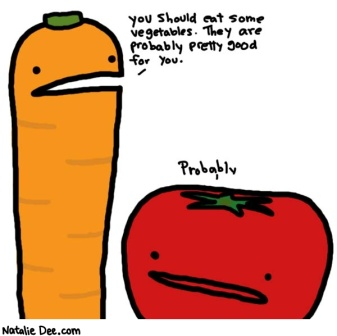Describe the following image. The image is a comical cartoon showcasing two anthropomorphic vegetables: a carrot and a tomato. The carrot, positioned on the left, is brightly colored orange with a green top. It has a slightly disgruntled face, giving it a humorous expression. On the right side is a red tomato with a green stem. The tomato also has a frowning face, mimicking the carrot's expression. There's a humorous dialogue between the two: above the carrot is text that reads, 'you should eat some vegetables. They are probably pretty good for you.' Below the tomato, the word 'Probably' is written, adding a playful twist and a hint of doubt to the statement. This cartoon cleverly encourages healthy eating in a fun and engaging way. 